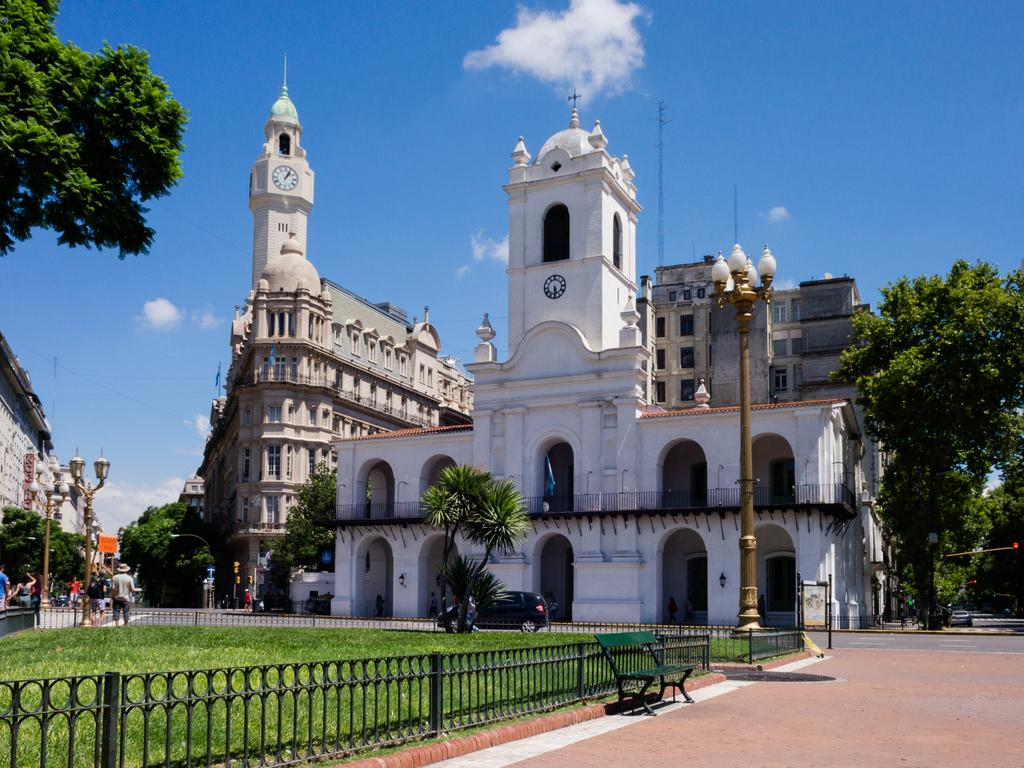What type of seating is present in the image? There is a bench in the image. What can be seen on the left side of the image? There is a rail on the left side of the image. What type of ground surface is visible in the image? There is grass visible in the image. What can be seen in the background of the image? There are buildings, trees, and clouds in the sky in the background of the image. How many sisters are sitting on the shelf in the image? There is no shelf or sisters present in the image. What type of view can be seen from the bench in the image? The image does not provide enough information to determine the view from the bench. 